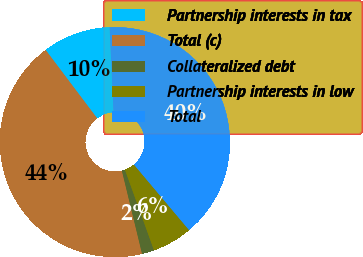Convert chart to OTSL. <chart><loc_0><loc_0><loc_500><loc_500><pie_chart><fcel>Partnership interests in tax<fcel>Total (c)<fcel>Collateralized debt<fcel>Partnership interests in low<fcel>Total<nl><fcel>9.54%<fcel>43.51%<fcel>1.72%<fcel>5.63%<fcel>39.6%<nl></chart> 